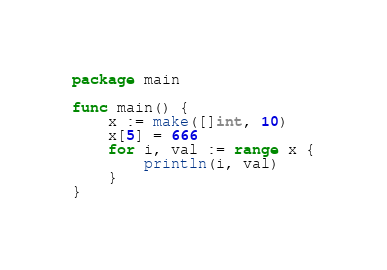<code> <loc_0><loc_0><loc_500><loc_500><_Go_>package main

func main() {
	x := make([]int, 10)
	x[5] = 666
	for i, val := range x {
		println(i, val)
	}
}
</code> 